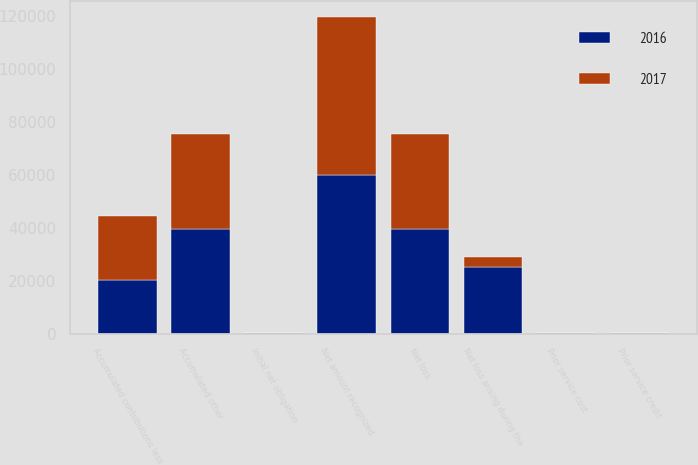Convert chart to OTSL. <chart><loc_0><loc_0><loc_500><loc_500><stacked_bar_chart><ecel><fcel>Initial net obligation<fcel>Prior service credit<fcel>Net loss<fcel>Accumulated other<fcel>Accumulated contributions less<fcel>Net amount recognized<fcel>Prior service cost<fcel>Net loss arising during the<nl><fcel>2017<fcel>10<fcel>45<fcel>35779<fcel>35834<fcel>24066<fcel>59900<fcel>176<fcel>3949<nl><fcel>2016<fcel>24<fcel>148<fcel>39647<fcel>39523<fcel>20365<fcel>59888<fcel>142<fcel>24985<nl></chart> 